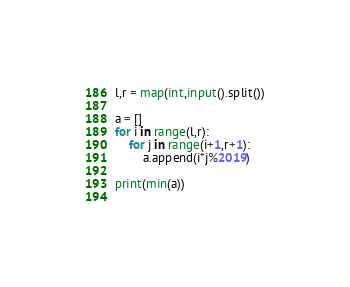Convert code to text. <code><loc_0><loc_0><loc_500><loc_500><_Python_>l,r = map(int,input().split())

a = []
for i in range(l,r):
    for j in range(i+1,r+1):
        a.append(i*j%2019)

print(min(a))
        
</code> 